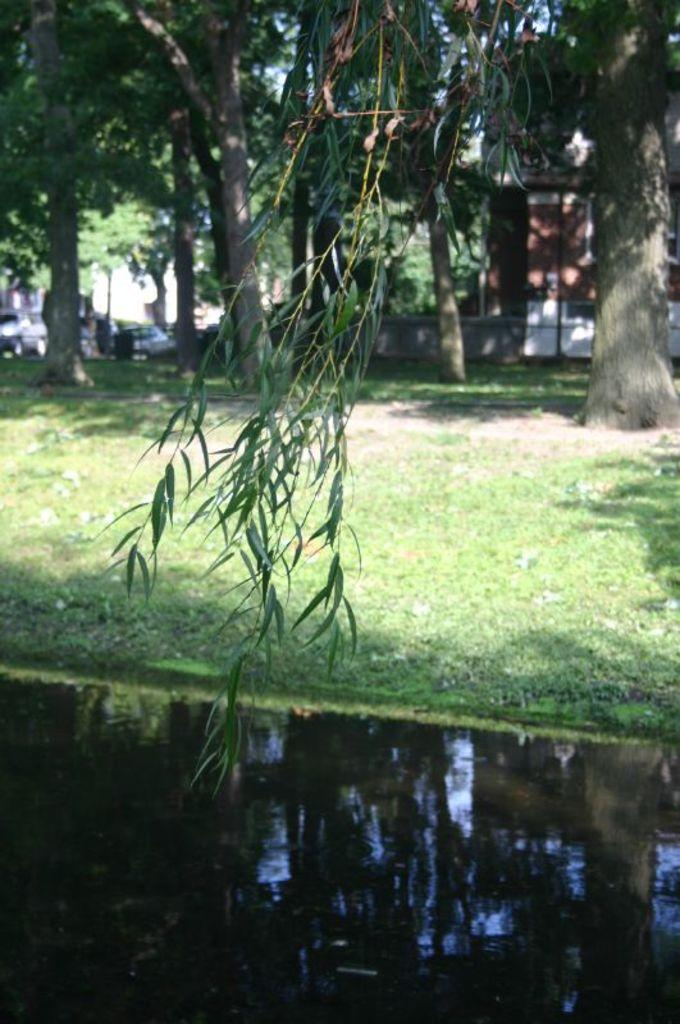What type of natural environment is depicted in the image? The image contains water, grass, and trees, which are elements of a natural environment. What type of man-made structures are present in the image? There is a vehicle and a building in the image. Can you describe the setting of the image? The image features a natural environment with water, grass, and trees, as well as man-made structures such as a vehicle and a building. What type of house is visible in the image? There is no house present in the image; it features a building, but not a house. What type of plate is being used by the father in the image? There is no father or plate present in the image. 